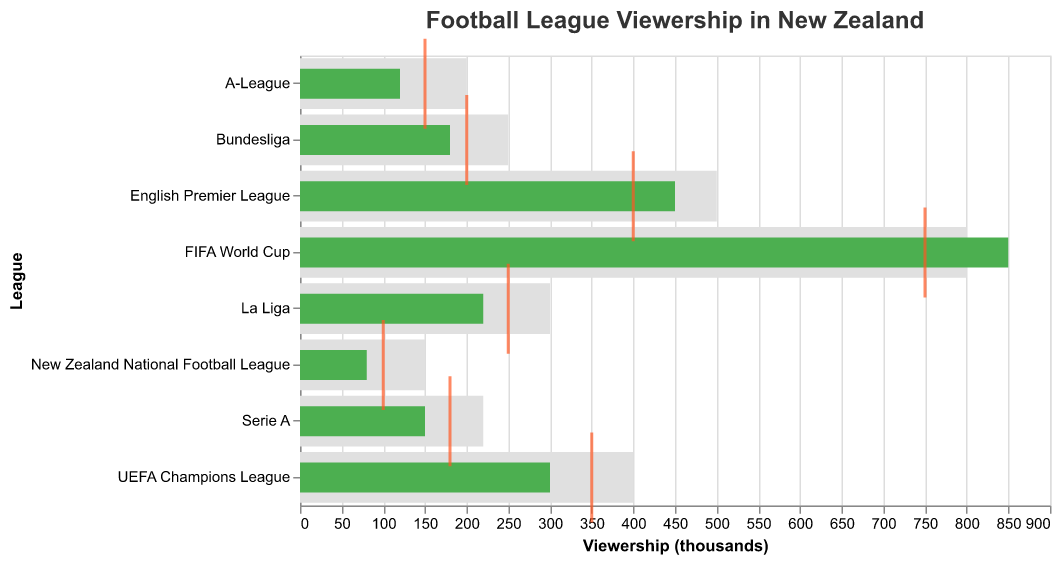How many leagues have their actual viewership surpass the benchmark viewership? The figure shows actual, projected, and benchmark viewerships for various football leagues. By comparing the actual viewership to the benchmark, we see that only the FIFA World Cup (850 actual vs. 800 benchmark) exceeds its benchmark viewership. All other leagues have actual viewerships below their benchmarks.
Answer: 1 Which league has the highest actual viewership, and what is the value? The figure shows the actual viewership values for different leagues. We compare these values and see that the FIFA World Cup has the highest actual viewership at 850 thousand viewers.
Answer: FIFA World Cup, 850 Is the actual viewership for the English Premier League above or below its benchmark figure? By looking at the bar representing the English Premier League, we see the actual viewership (450 thousand) is below the benchmark (500 thousand).
Answer: Below What is the difference between the projected and benchmark viewership for the New Zealand National Football League? By comparing the projected (100 thousand) and benchmark (150 thousand) viewership for the New Zealand National Football League, the difference is 150 - 100 = 50 thousand.
Answer: 50 How many leagues have actual viewership above 200 thousand? The figure indicates the actual viewership for each league. Leagues with actual viewership above 200 thousand are English Premier League (450), FIFA World Cup (850), La Liga (220), and UEFA Champions League (300).
Answer: 4 Which league has the lowest projected viewership, and what is the value? The lowest projected viewership can be found by comparing the projected viewerships of all leagues. The New Zealand National Football League has the lowest projected viewership at 100 thousand viewers.
Answer: New Zealand National Football League, 100 For the Bundesliga, how much lower is the actual viewership compared to the benchmark? The actual viewership for the Bundesliga is 180 thousand while the benchmark is 250 thousand. The difference is 250 - 180 = 70 thousand.
Answer: 70 Which league exceeded its projected viewership by the largest margin? We need to find the league with the highest positive difference between actual and projected viewership.
1. English Premier League: 450 - 400 = 50
2. A-League: 120 - 150 = -30
3. FIFA World Cup: 850 - 750 = 100
4. UEFA Champions League: 300 - 350 = -50
5. New Zealand National Football League: 80 - 100 = -20
6. Bundesliga: 180 - 200 = -20
7. La Liga: 220 - 250 = -30
8. Serie A: 150 - 180 = -30
The FIFA World Cup exceeds its projected viewership by the largest margin of 100 thousand.
Answer: FIFA World Cup 